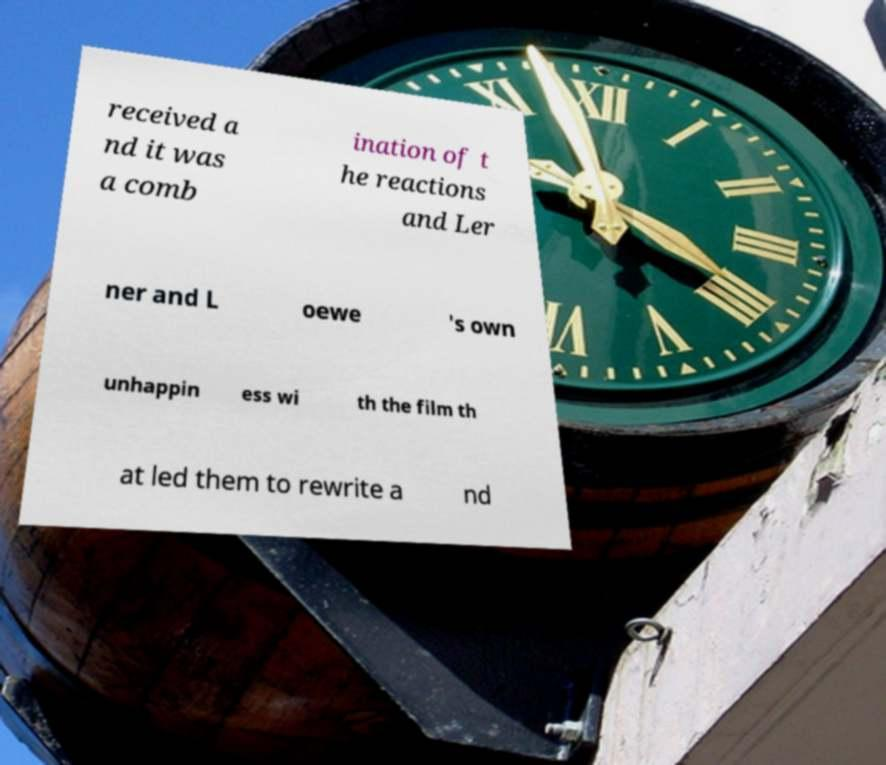I need the written content from this picture converted into text. Can you do that? received a nd it was a comb ination of t he reactions and Ler ner and L oewe 's own unhappin ess wi th the film th at led them to rewrite a nd 